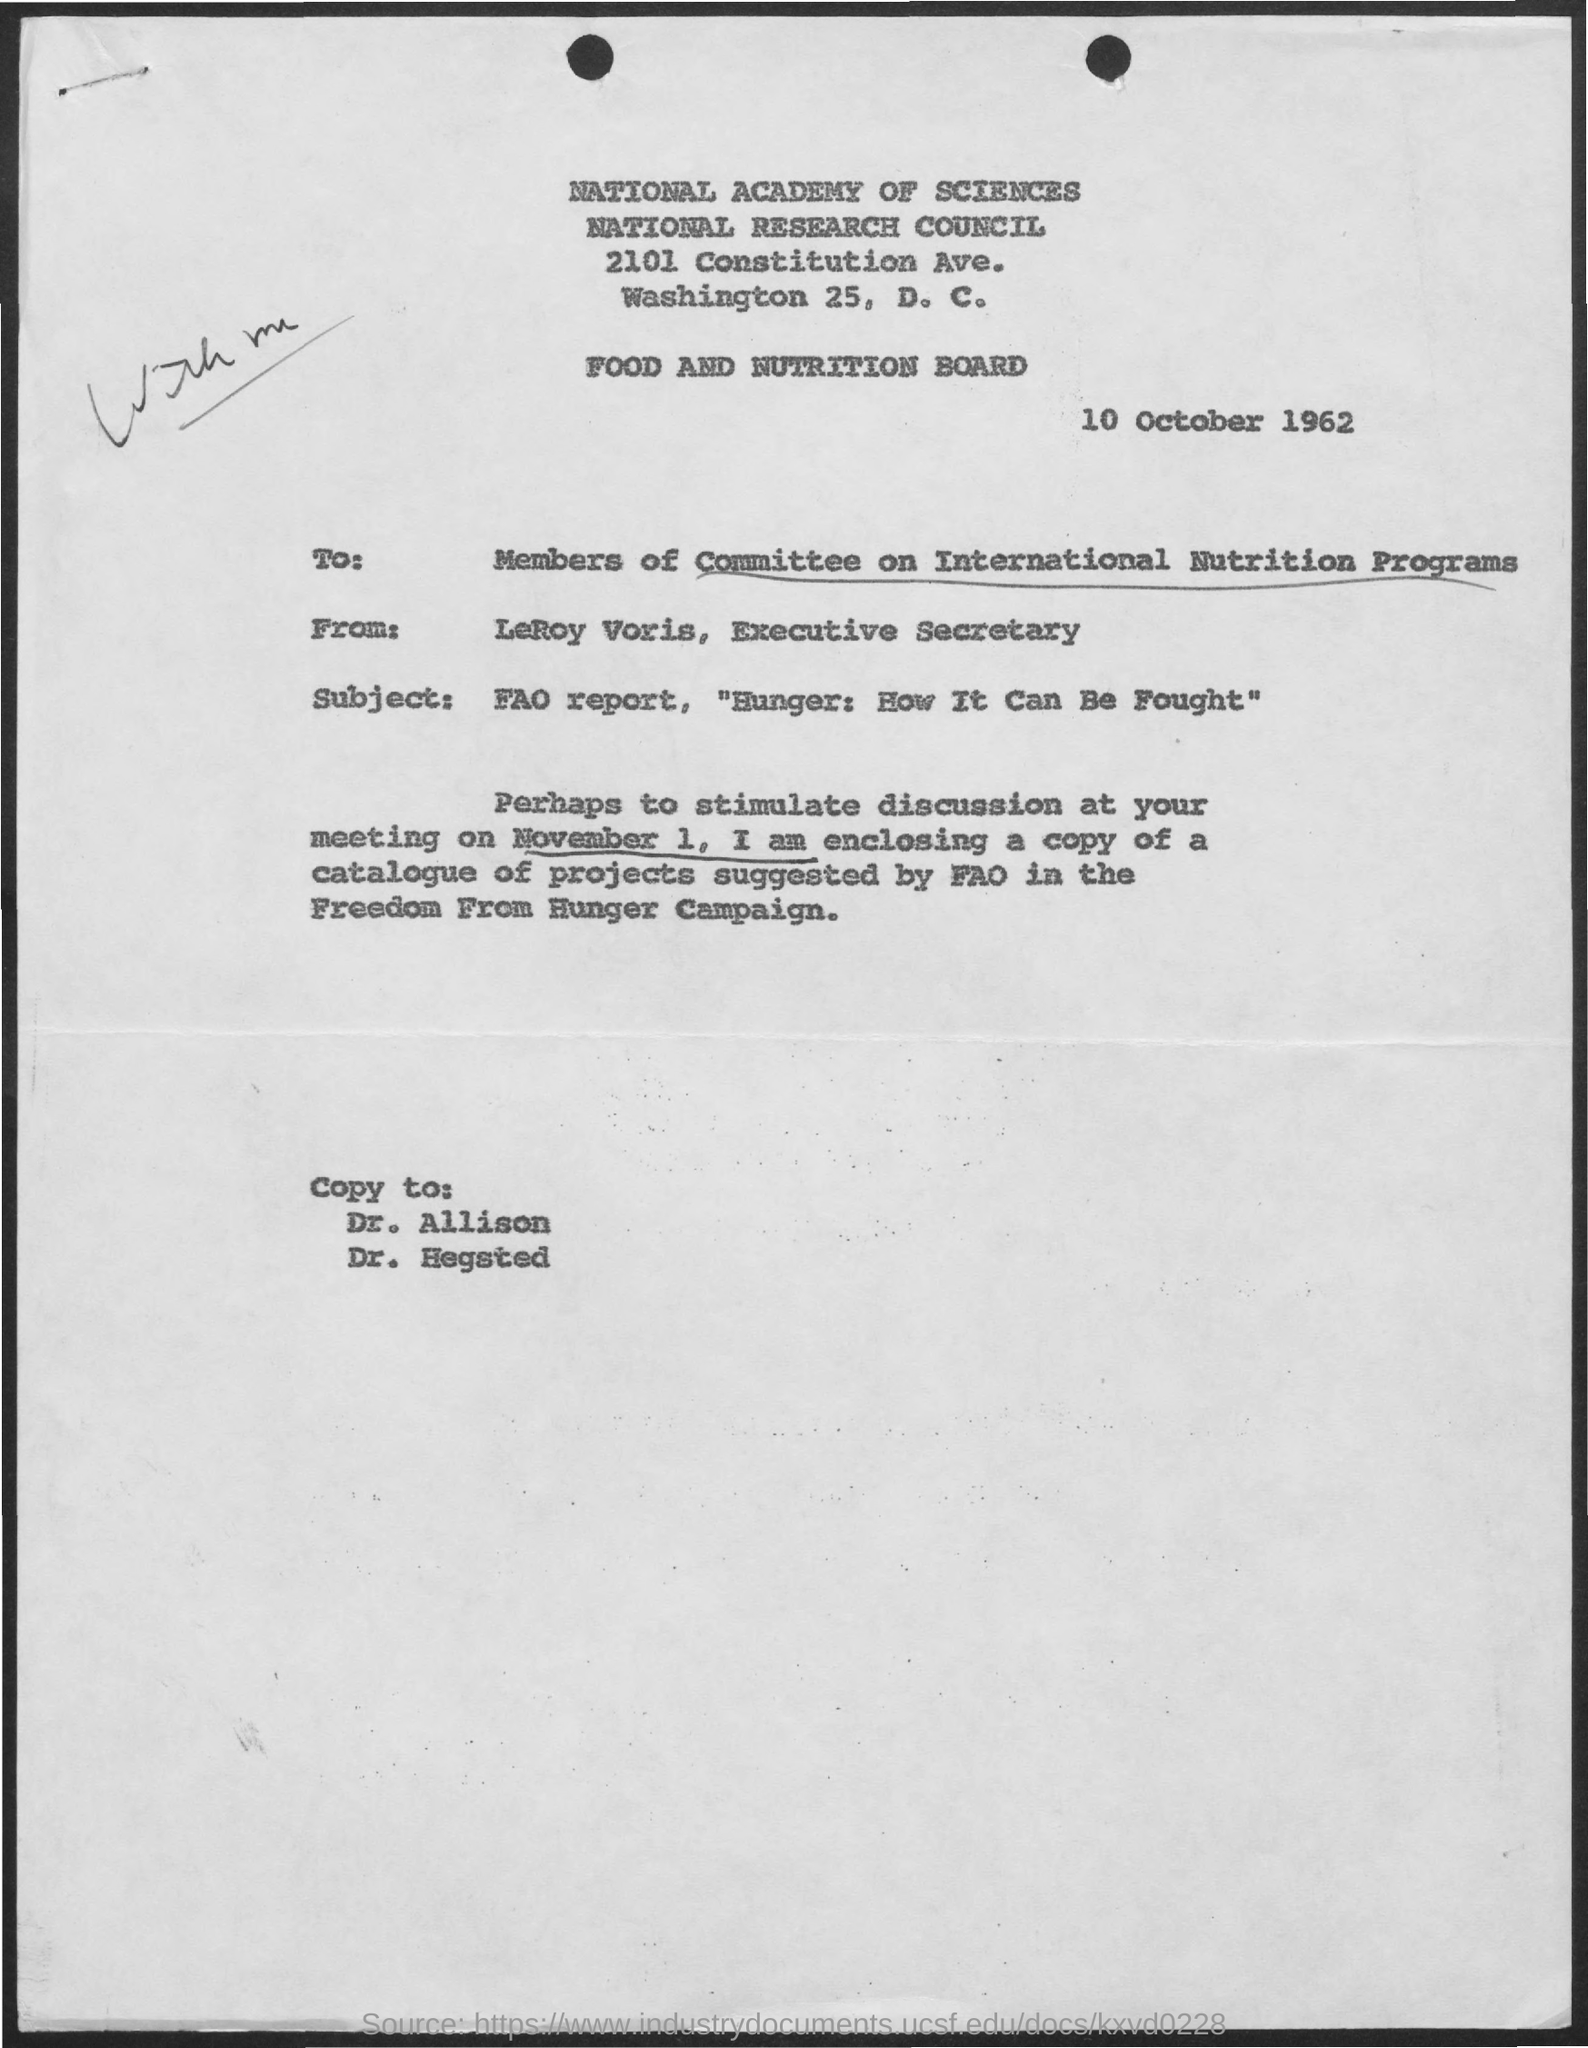To whom, this letter is addressed?
Offer a terse response. Members of Committee on International Nutrition Programs. Who is the sender of this letter?
Your response must be concise. LeRoy Voris, Executive Secretary. What is the subject mentioned in this letter?
Ensure brevity in your answer.  FAO report, "Hunger: How It can be Fought". What is the letter dated?
Give a very brief answer. 10 October 1962. 